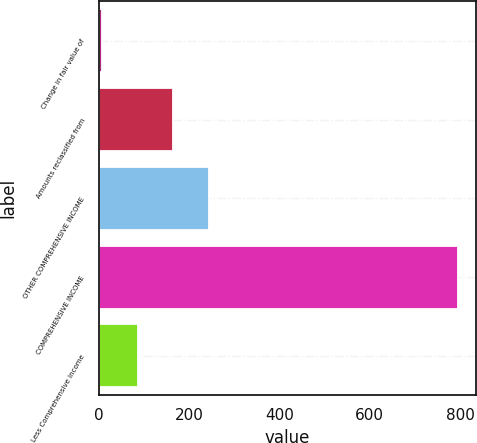Convert chart to OTSL. <chart><loc_0><loc_0><loc_500><loc_500><bar_chart><fcel>Change in fair value of<fcel>Amounts reclassified from<fcel>OTHER COMPREHENSIVE INCOME<fcel>COMPREHENSIVE INCOME<fcel>Less Comprehensive income<nl><fcel>7<fcel>164.6<fcel>243.4<fcel>795<fcel>85.8<nl></chart> 